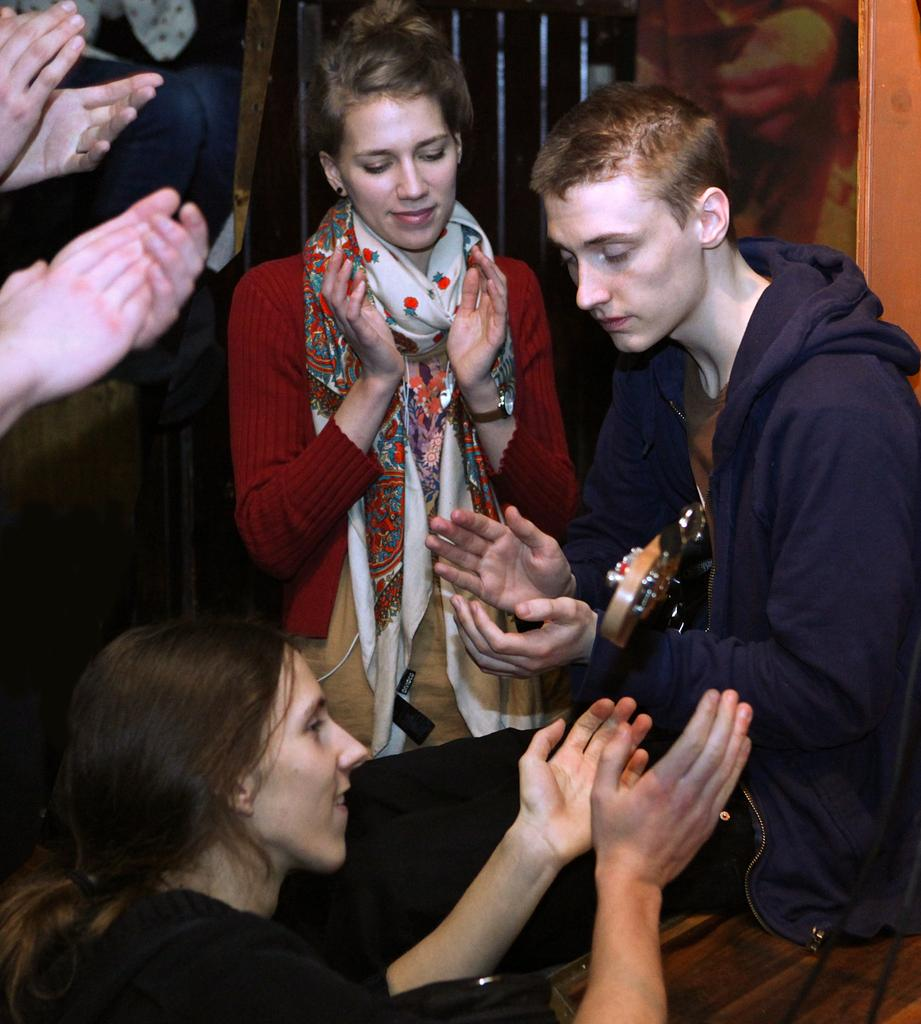How many people are the people are arranged in the image? There are two persons sitting at the bottom of the image, and there are people standing beside the sitting persons. What is visible behind the people in the image? There is a wall visible behind the people. How many deer can be seen grazing in the background of the image? There are no deer present in the image; it only features people sitting and standing with a wall in the background. 